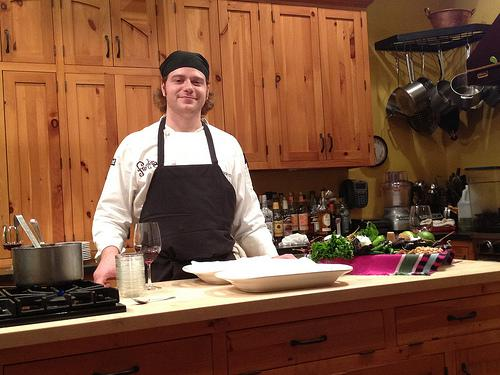Question: why is the man wearing chef's clothing?
Choices:
A. He is dressing up for Halloween.
B. He is posing.
C. He is cooking.
D. He is a model.
Answer with the letter. Answer: C Question: what color are the cabinet handles?
Choices:
A. Orange.
B. Black.
C. White.
D. Gold.
Answer with the letter. Answer: B Question: what color are the walls?
Choices:
A. White.
B. Yellow.
C. Tan.
D. Red.
Answer with the letter. Answer: B Question: where is the man standing?
Choices:
A. In the pond.
B. Over the crowd.
C. Behind the island.
D. On stage.
Answer with the letter. Answer: C Question: what is on the range?
Choices:
A. A bowl.
B. A pot.
C. A griddle.
D. A kettle.
Answer with the letter. Answer: B Question: what is on top of the pot rack?
Choices:
A. A copper pot.
B. A steel pot.
C. Dust.
D. Forks.
Answer with the letter. Answer: A Question: where was the picture taken?
Choices:
A. Bar.
B. In a kitchen.
C. Bathrrom.
D. Kitchen.
Answer with the letter. Answer: B Question: where was the picture taken?
Choices:
A. In a kitchen.
B. On a screened-in porch.
C. In the living room.
D. In his hospital bed.
Answer with the letter. Answer: A 